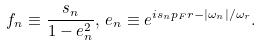Convert formula to latex. <formula><loc_0><loc_0><loc_500><loc_500>f _ { n } \equiv \frac { s _ { n } } { 1 - e _ { n } ^ { 2 } } , \, e _ { n } \equiv e ^ { i s _ { n } p _ { F } r - | \omega _ { n } | / \omega _ { r } } .</formula> 